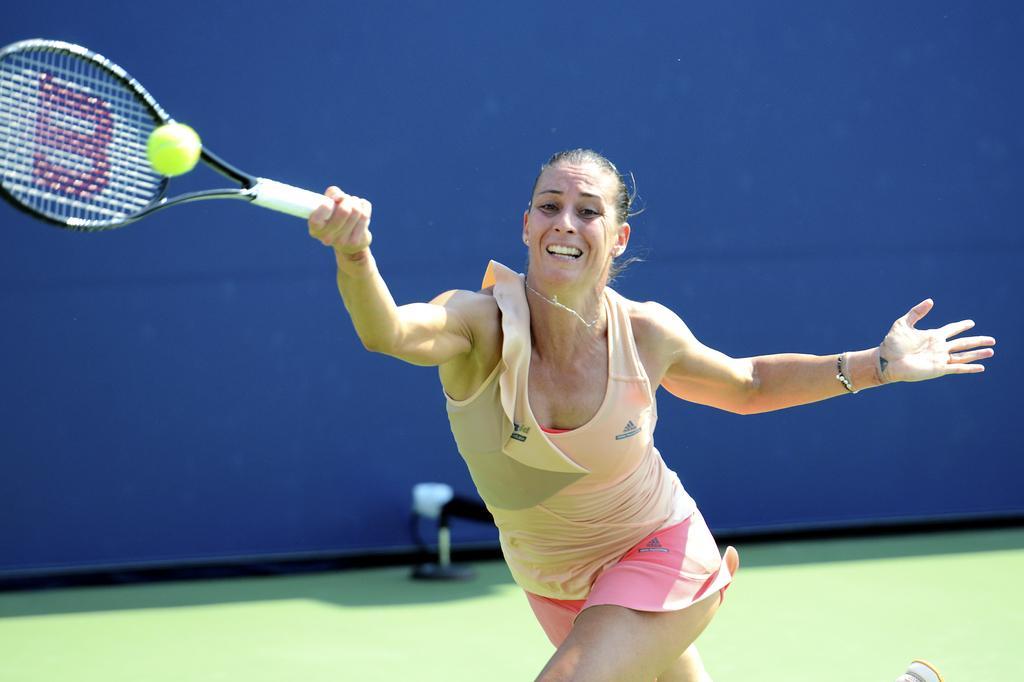How would you summarize this image in a sentence or two? In the center of the image there is a lady playing tennis. There is a tennis bat in her hand. She is about to hit the tennis ball with her bat and there is a wall behind her. 